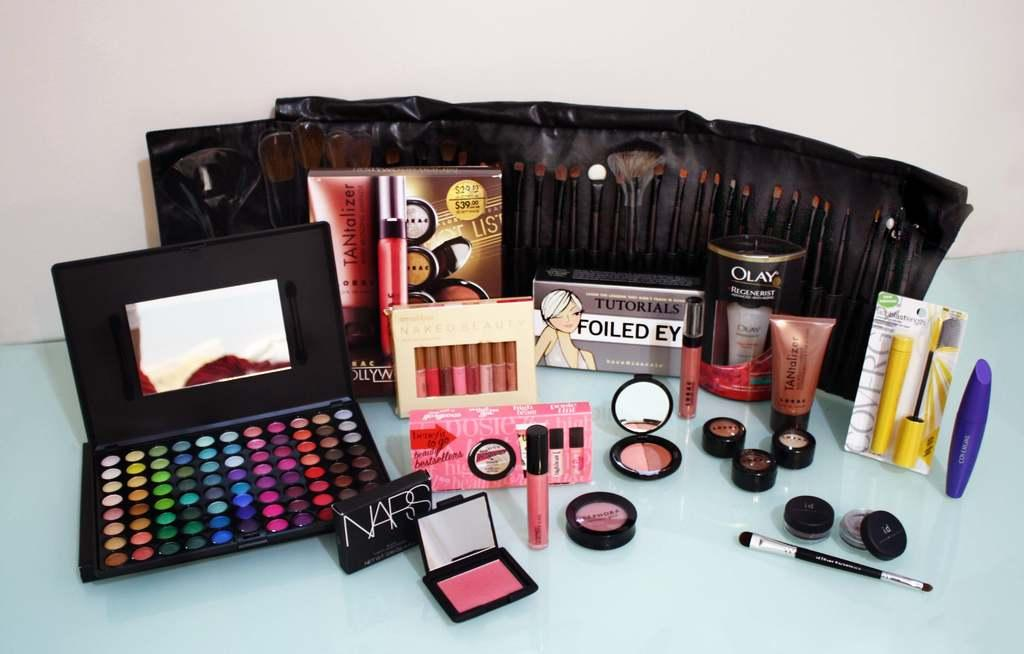Provide a one-sentence caption for the provided image. A large collection of make up including NARS. 